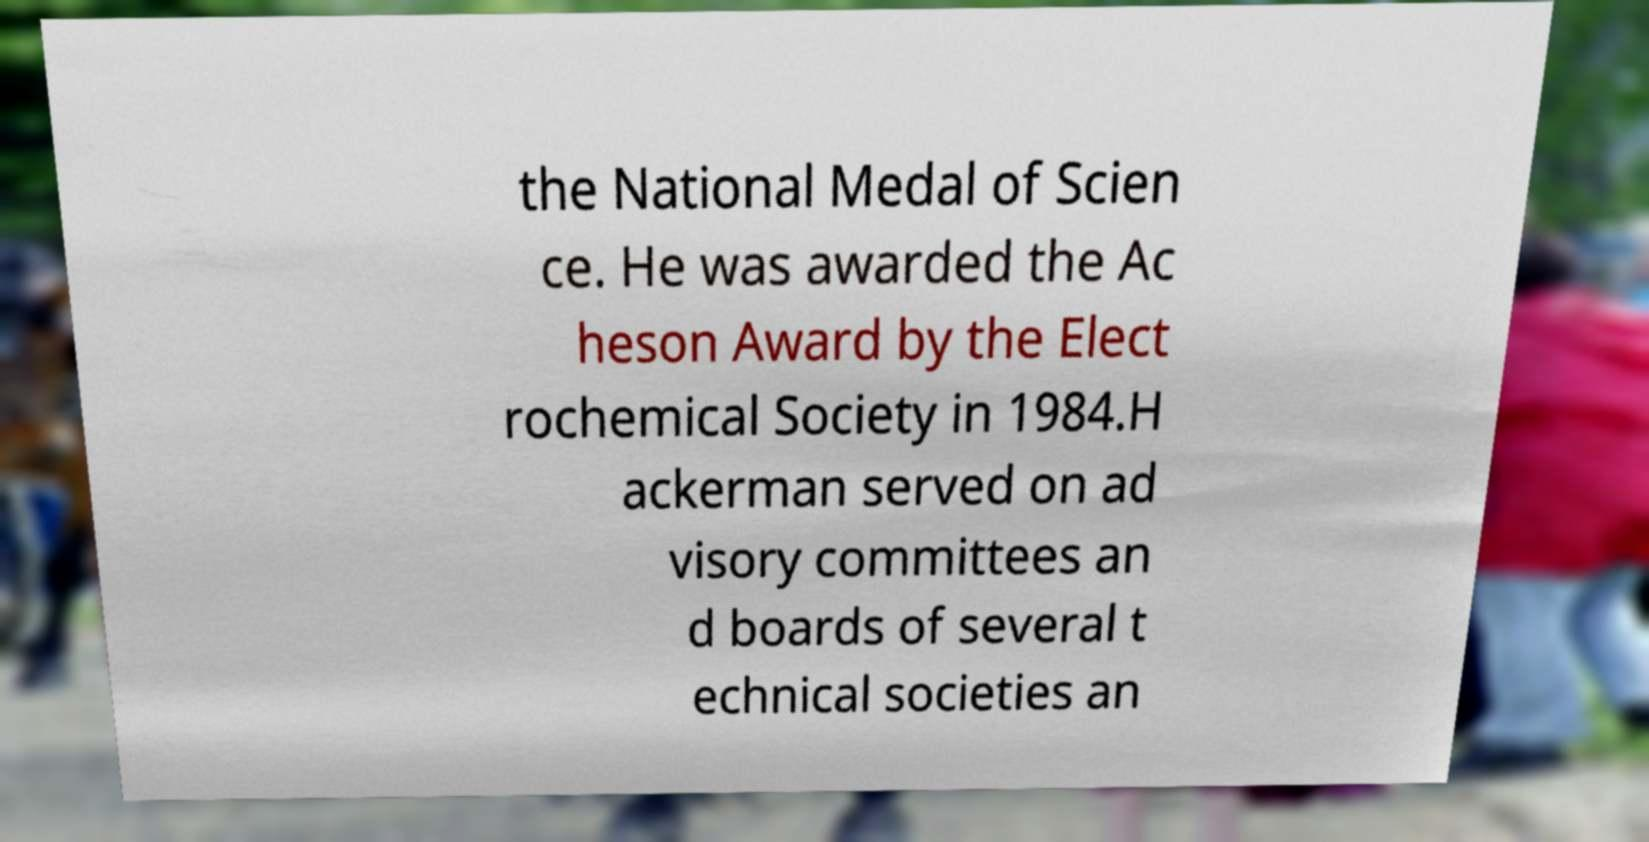Please read and relay the text visible in this image. What does it say? the National Medal of Scien ce. He was awarded the Ac heson Award by the Elect rochemical Society in 1984.H ackerman served on ad visory committees an d boards of several t echnical societies an 